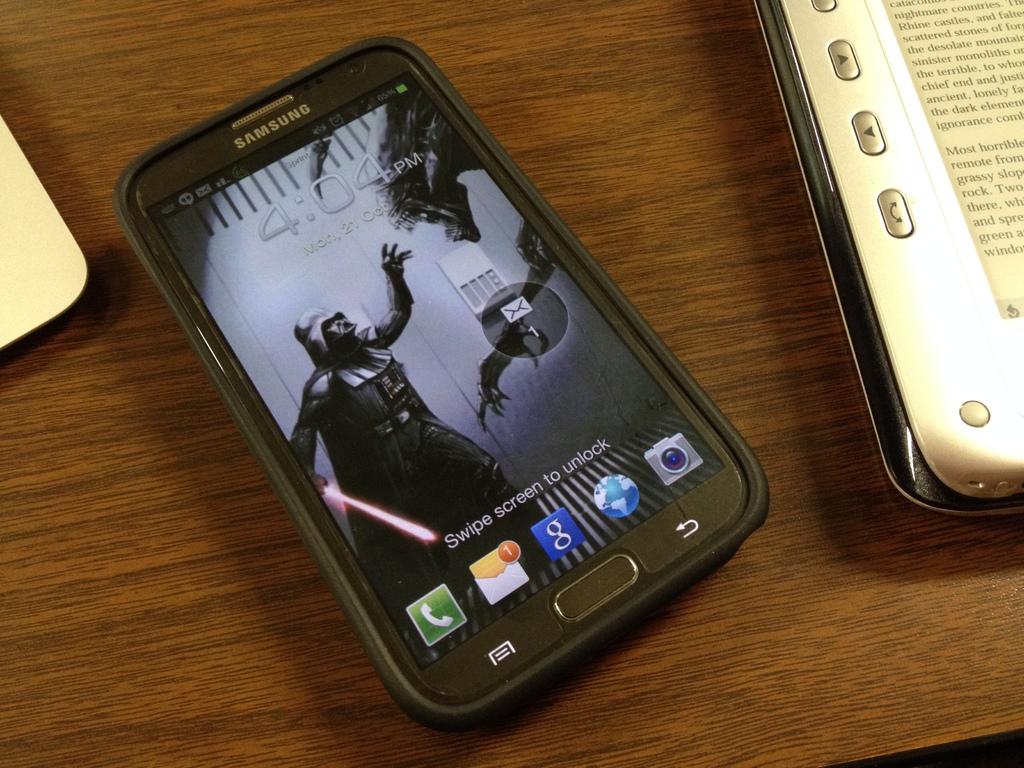What time does the watch read?
Offer a very short reply. Unanswerable. How many messages does the phone have?
Provide a succinct answer. 1. 